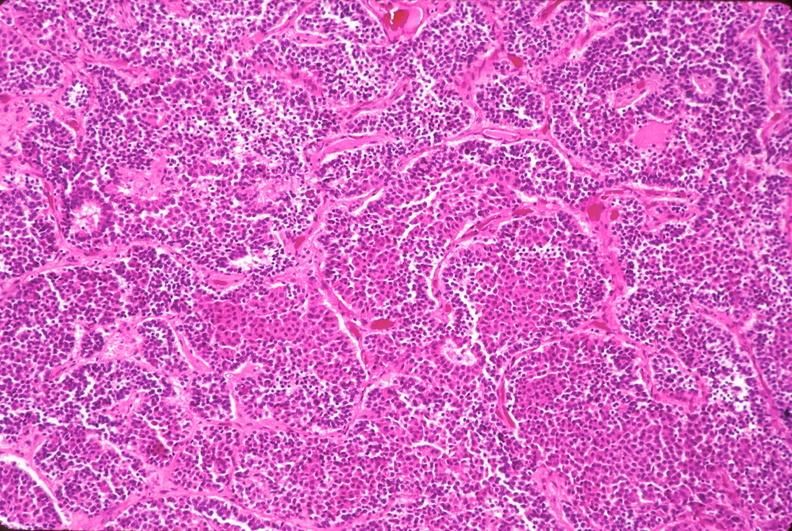s polycystic disease present?
Answer the question using a single word or phrase. No 